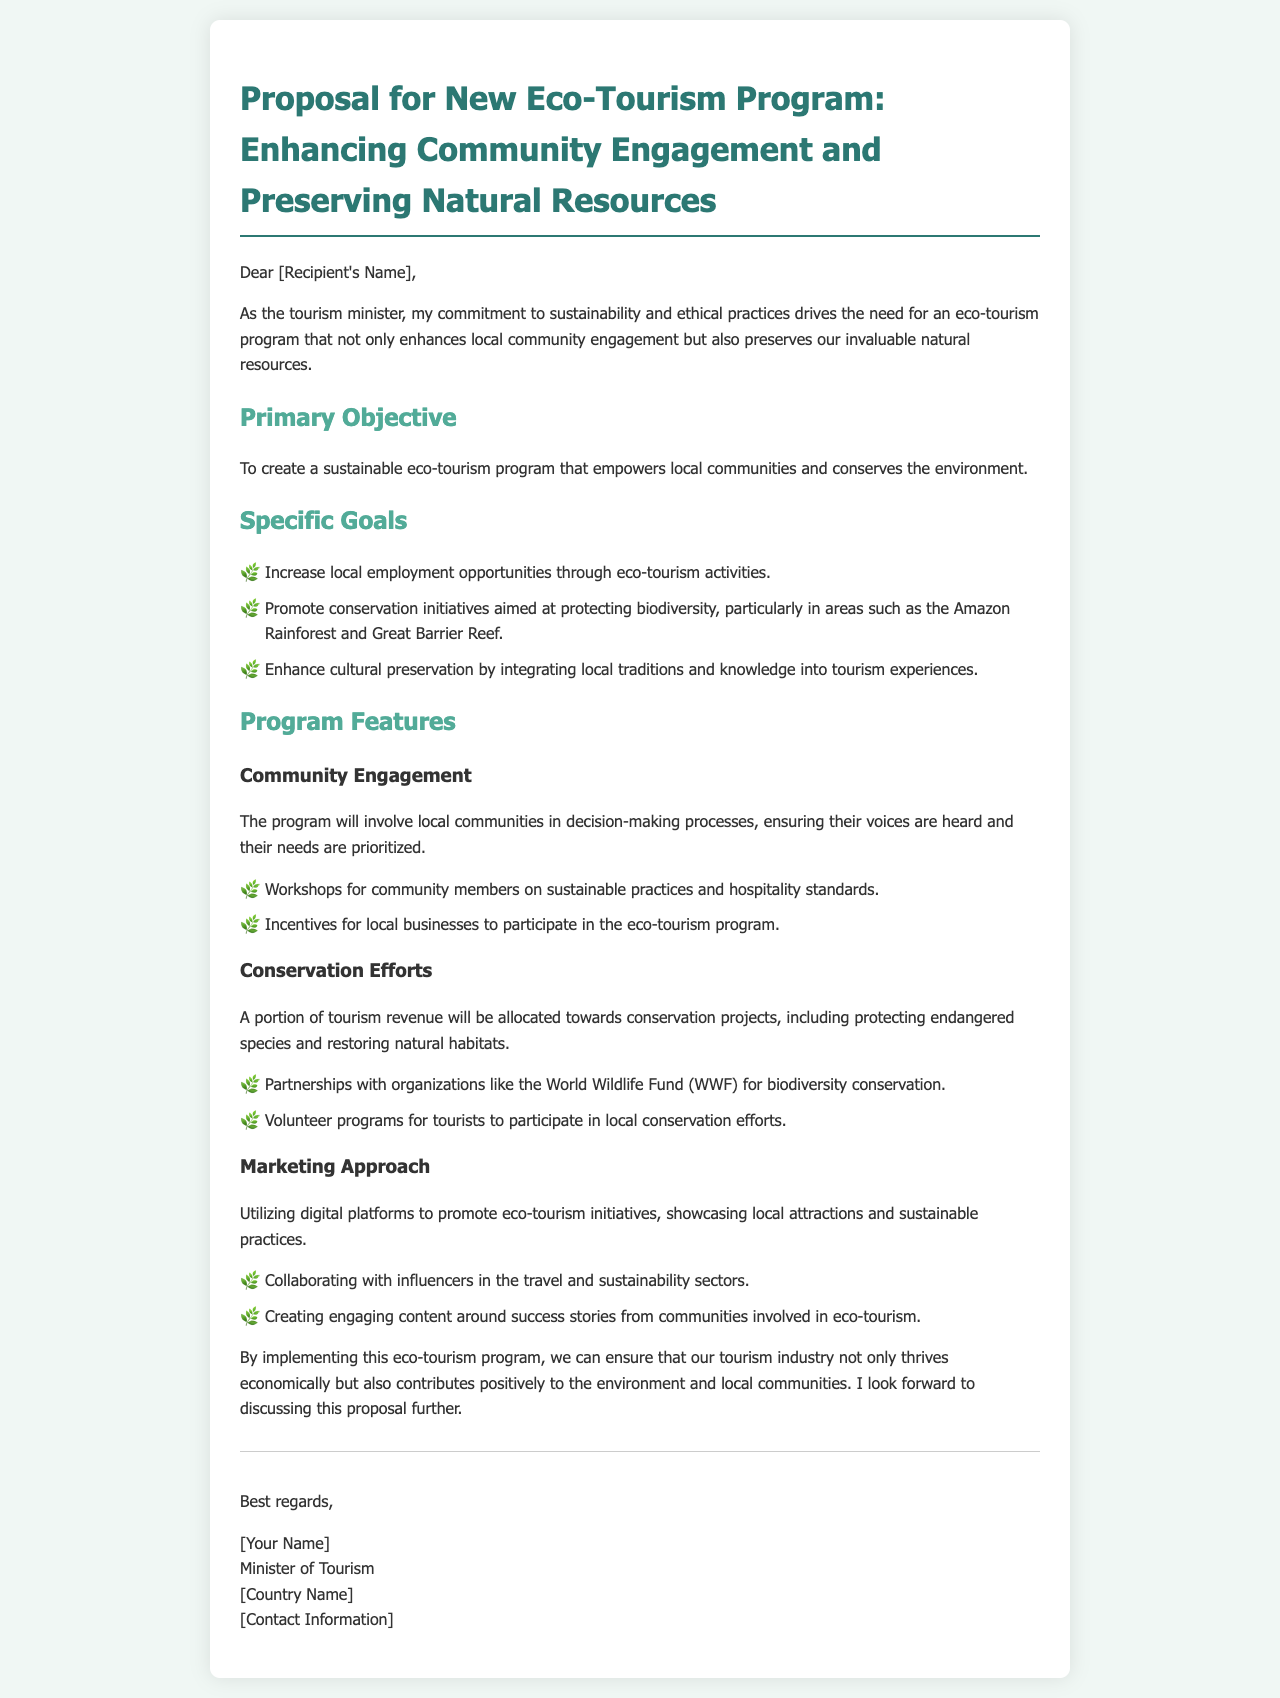What is the primary objective of the program? The primary objective is stated explicitly in the document as creating a sustainable eco-tourism program.
Answer: Create a sustainable eco-tourism program How many specific goals are outlined in the proposal? There are three specific goals listed under the "Specific Goals" section.
Answer: Three Which ecological area is mentioned for conservation initiatives? The document specifies the Amazon Rainforest as one of the areas for conservation initiatives.
Answer: Amazon Rainforest What type of workshops will be offered to community members? The program will include workshops on sustainable practices and hospitality standards.
Answer: Sustainable practices and hospitality standards What organization will the program partner with for biodiversity conservation? The proposal mentions a partnership with the World Wildlife Fund.
Answer: World Wildlife Fund How will the program involve community members? The document highlights local communities' involvement in decision-making processes as a method of engagement.
Answer: Decision-making processes What marketing approach will be utilized to promote eco-tourism? The proposal indicates that digital platforms will be used for marketing eco-tourism initiatives.
Answer: Digital platforms What kind of content will be created for marketing? Engaging content around success stories from communities involved in eco-tourism will be created.
Answer: Success stories 